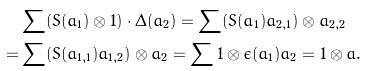<formula> <loc_0><loc_0><loc_500><loc_500>& \sum ( S ( a _ { 1 } ) \otimes 1 ) \cdot \Delta ( a _ { 2 } ) = \sum ( S ( a _ { 1 } ) a _ { 2 , 1 } ) \otimes a _ { 2 , 2 } \\ = & \sum ( S ( a _ { 1 , 1 } ) a _ { 1 , 2 } ) \otimes a _ { 2 } = \sum 1 \otimes \epsilon ( a _ { 1 } ) a _ { 2 } = 1 \otimes a .</formula> 